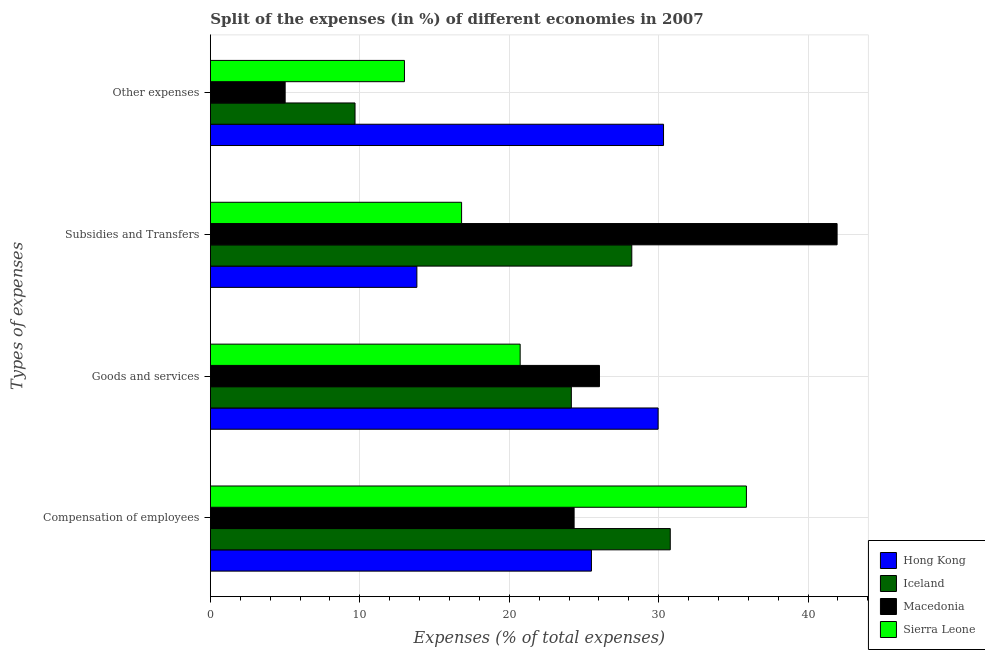Are the number of bars per tick equal to the number of legend labels?
Make the answer very short. Yes. Are the number of bars on each tick of the Y-axis equal?
Ensure brevity in your answer.  Yes. How many bars are there on the 4th tick from the bottom?
Your answer should be compact. 4. What is the label of the 1st group of bars from the top?
Give a very brief answer. Other expenses. What is the percentage of amount spent on other expenses in Sierra Leone?
Your answer should be compact. 12.99. Across all countries, what is the maximum percentage of amount spent on compensation of employees?
Provide a succinct answer. 35.87. Across all countries, what is the minimum percentage of amount spent on other expenses?
Your answer should be compact. 5. In which country was the percentage of amount spent on goods and services maximum?
Offer a very short reply. Hong Kong. In which country was the percentage of amount spent on compensation of employees minimum?
Your answer should be very brief. Macedonia. What is the total percentage of amount spent on subsidies in the graph?
Make the answer very short. 100.78. What is the difference between the percentage of amount spent on subsidies in Iceland and that in Sierra Leone?
Make the answer very short. 11.39. What is the difference between the percentage of amount spent on other expenses in Iceland and the percentage of amount spent on goods and services in Macedonia?
Provide a short and direct response. -16.36. What is the average percentage of amount spent on compensation of employees per country?
Offer a very short reply. 29.12. What is the difference between the percentage of amount spent on subsidies and percentage of amount spent on other expenses in Iceland?
Give a very brief answer. 18.52. In how many countries, is the percentage of amount spent on compensation of employees greater than 32 %?
Your answer should be compact. 1. What is the ratio of the percentage of amount spent on goods and services in Macedonia to that in Sierra Leone?
Ensure brevity in your answer.  1.26. Is the difference between the percentage of amount spent on subsidies in Macedonia and Hong Kong greater than the difference between the percentage of amount spent on goods and services in Macedonia and Hong Kong?
Your response must be concise. Yes. What is the difference between the highest and the second highest percentage of amount spent on subsidies?
Your answer should be very brief. 13.74. What is the difference between the highest and the lowest percentage of amount spent on goods and services?
Offer a very short reply. 9.23. In how many countries, is the percentage of amount spent on subsidies greater than the average percentage of amount spent on subsidies taken over all countries?
Provide a succinct answer. 2. Is the sum of the percentage of amount spent on subsidies in Iceland and Macedonia greater than the maximum percentage of amount spent on other expenses across all countries?
Offer a terse response. Yes. Is it the case that in every country, the sum of the percentage of amount spent on other expenses and percentage of amount spent on subsidies is greater than the sum of percentage of amount spent on compensation of employees and percentage of amount spent on goods and services?
Keep it short and to the point. No. What does the 3rd bar from the top in Subsidies and Transfers represents?
Keep it short and to the point. Iceland. What does the 2nd bar from the bottom in Goods and services represents?
Provide a short and direct response. Iceland. Is it the case that in every country, the sum of the percentage of amount spent on compensation of employees and percentage of amount spent on goods and services is greater than the percentage of amount spent on subsidies?
Your answer should be compact. Yes. How many bars are there?
Provide a succinct answer. 16. How many countries are there in the graph?
Give a very brief answer. 4. What is the difference between two consecutive major ticks on the X-axis?
Keep it short and to the point. 10. Are the values on the major ticks of X-axis written in scientific E-notation?
Your response must be concise. No. Does the graph contain any zero values?
Offer a very short reply. No. What is the title of the graph?
Your answer should be very brief. Split of the expenses (in %) of different economies in 2007. Does "Venezuela" appear as one of the legend labels in the graph?
Your answer should be compact. No. What is the label or title of the X-axis?
Offer a very short reply. Expenses (% of total expenses). What is the label or title of the Y-axis?
Keep it short and to the point. Types of expenses. What is the Expenses (% of total expenses) in Hong Kong in Compensation of employees?
Give a very brief answer. 25.5. What is the Expenses (% of total expenses) of Iceland in Compensation of employees?
Offer a terse response. 30.78. What is the Expenses (% of total expenses) of Macedonia in Compensation of employees?
Your response must be concise. 24.34. What is the Expenses (% of total expenses) of Sierra Leone in Compensation of employees?
Make the answer very short. 35.87. What is the Expenses (% of total expenses) of Hong Kong in Goods and services?
Ensure brevity in your answer.  29.97. What is the Expenses (% of total expenses) of Iceland in Goods and services?
Provide a succinct answer. 24.16. What is the Expenses (% of total expenses) in Macedonia in Goods and services?
Provide a succinct answer. 26.04. What is the Expenses (% of total expenses) of Sierra Leone in Goods and services?
Your answer should be compact. 20.73. What is the Expenses (% of total expenses) in Hong Kong in Subsidies and Transfers?
Give a very brief answer. 13.82. What is the Expenses (% of total expenses) of Iceland in Subsidies and Transfers?
Make the answer very short. 28.2. What is the Expenses (% of total expenses) of Macedonia in Subsidies and Transfers?
Provide a succinct answer. 41.94. What is the Expenses (% of total expenses) of Sierra Leone in Subsidies and Transfers?
Your answer should be compact. 16.81. What is the Expenses (% of total expenses) of Hong Kong in Other expenses?
Offer a very short reply. 30.33. What is the Expenses (% of total expenses) in Iceland in Other expenses?
Your response must be concise. 9.68. What is the Expenses (% of total expenses) in Macedonia in Other expenses?
Your answer should be very brief. 5. What is the Expenses (% of total expenses) of Sierra Leone in Other expenses?
Ensure brevity in your answer.  12.99. Across all Types of expenses, what is the maximum Expenses (% of total expenses) in Hong Kong?
Give a very brief answer. 30.33. Across all Types of expenses, what is the maximum Expenses (% of total expenses) in Iceland?
Your answer should be very brief. 30.78. Across all Types of expenses, what is the maximum Expenses (% of total expenses) of Macedonia?
Offer a terse response. 41.94. Across all Types of expenses, what is the maximum Expenses (% of total expenses) in Sierra Leone?
Provide a succinct answer. 35.87. Across all Types of expenses, what is the minimum Expenses (% of total expenses) of Hong Kong?
Offer a terse response. 13.82. Across all Types of expenses, what is the minimum Expenses (% of total expenses) of Iceland?
Provide a succinct answer. 9.68. Across all Types of expenses, what is the minimum Expenses (% of total expenses) of Macedonia?
Give a very brief answer. 5. Across all Types of expenses, what is the minimum Expenses (% of total expenses) in Sierra Leone?
Ensure brevity in your answer.  12.99. What is the total Expenses (% of total expenses) in Hong Kong in the graph?
Your answer should be very brief. 99.61. What is the total Expenses (% of total expenses) of Iceland in the graph?
Ensure brevity in your answer.  92.82. What is the total Expenses (% of total expenses) of Macedonia in the graph?
Ensure brevity in your answer.  97.33. What is the total Expenses (% of total expenses) of Sierra Leone in the graph?
Provide a succinct answer. 86.4. What is the difference between the Expenses (% of total expenses) in Hong Kong in Compensation of employees and that in Goods and services?
Your response must be concise. -4.46. What is the difference between the Expenses (% of total expenses) in Iceland in Compensation of employees and that in Goods and services?
Your answer should be compact. 6.62. What is the difference between the Expenses (% of total expenses) of Macedonia in Compensation of employees and that in Goods and services?
Keep it short and to the point. -1.7. What is the difference between the Expenses (% of total expenses) in Sierra Leone in Compensation of employees and that in Goods and services?
Your answer should be compact. 15.14. What is the difference between the Expenses (% of total expenses) in Hong Kong in Compensation of employees and that in Subsidies and Transfers?
Ensure brevity in your answer.  11.68. What is the difference between the Expenses (% of total expenses) in Iceland in Compensation of employees and that in Subsidies and Transfers?
Your response must be concise. 2.57. What is the difference between the Expenses (% of total expenses) in Macedonia in Compensation of employees and that in Subsidies and Transfers?
Keep it short and to the point. -17.6. What is the difference between the Expenses (% of total expenses) of Sierra Leone in Compensation of employees and that in Subsidies and Transfers?
Make the answer very short. 19.06. What is the difference between the Expenses (% of total expenses) in Hong Kong in Compensation of employees and that in Other expenses?
Offer a very short reply. -4.82. What is the difference between the Expenses (% of total expenses) of Iceland in Compensation of employees and that in Other expenses?
Provide a short and direct response. 21.1. What is the difference between the Expenses (% of total expenses) in Macedonia in Compensation of employees and that in Other expenses?
Keep it short and to the point. 19.34. What is the difference between the Expenses (% of total expenses) in Sierra Leone in Compensation of employees and that in Other expenses?
Keep it short and to the point. 22.89. What is the difference between the Expenses (% of total expenses) of Hong Kong in Goods and services and that in Subsidies and Transfers?
Make the answer very short. 16.15. What is the difference between the Expenses (% of total expenses) of Iceland in Goods and services and that in Subsidies and Transfers?
Your answer should be compact. -4.05. What is the difference between the Expenses (% of total expenses) in Macedonia in Goods and services and that in Subsidies and Transfers?
Your answer should be very brief. -15.9. What is the difference between the Expenses (% of total expenses) in Sierra Leone in Goods and services and that in Subsidies and Transfers?
Ensure brevity in your answer.  3.92. What is the difference between the Expenses (% of total expenses) of Hong Kong in Goods and services and that in Other expenses?
Give a very brief answer. -0.36. What is the difference between the Expenses (% of total expenses) in Iceland in Goods and services and that in Other expenses?
Offer a terse response. 14.48. What is the difference between the Expenses (% of total expenses) in Macedonia in Goods and services and that in Other expenses?
Give a very brief answer. 21.04. What is the difference between the Expenses (% of total expenses) in Sierra Leone in Goods and services and that in Other expenses?
Keep it short and to the point. 7.74. What is the difference between the Expenses (% of total expenses) in Hong Kong in Subsidies and Transfers and that in Other expenses?
Ensure brevity in your answer.  -16.51. What is the difference between the Expenses (% of total expenses) of Iceland in Subsidies and Transfers and that in Other expenses?
Keep it short and to the point. 18.52. What is the difference between the Expenses (% of total expenses) of Macedonia in Subsidies and Transfers and that in Other expenses?
Your response must be concise. 36.94. What is the difference between the Expenses (% of total expenses) in Sierra Leone in Subsidies and Transfers and that in Other expenses?
Provide a succinct answer. 3.82. What is the difference between the Expenses (% of total expenses) in Hong Kong in Compensation of employees and the Expenses (% of total expenses) in Iceland in Goods and services?
Offer a terse response. 1.35. What is the difference between the Expenses (% of total expenses) of Hong Kong in Compensation of employees and the Expenses (% of total expenses) of Macedonia in Goods and services?
Offer a terse response. -0.54. What is the difference between the Expenses (% of total expenses) in Hong Kong in Compensation of employees and the Expenses (% of total expenses) in Sierra Leone in Goods and services?
Offer a very short reply. 4.77. What is the difference between the Expenses (% of total expenses) of Iceland in Compensation of employees and the Expenses (% of total expenses) of Macedonia in Goods and services?
Ensure brevity in your answer.  4.74. What is the difference between the Expenses (% of total expenses) in Iceland in Compensation of employees and the Expenses (% of total expenses) in Sierra Leone in Goods and services?
Give a very brief answer. 10.05. What is the difference between the Expenses (% of total expenses) of Macedonia in Compensation of employees and the Expenses (% of total expenses) of Sierra Leone in Goods and services?
Ensure brevity in your answer.  3.61. What is the difference between the Expenses (% of total expenses) of Hong Kong in Compensation of employees and the Expenses (% of total expenses) of Iceland in Subsidies and Transfers?
Make the answer very short. -2.7. What is the difference between the Expenses (% of total expenses) of Hong Kong in Compensation of employees and the Expenses (% of total expenses) of Macedonia in Subsidies and Transfers?
Offer a terse response. -16.44. What is the difference between the Expenses (% of total expenses) in Hong Kong in Compensation of employees and the Expenses (% of total expenses) in Sierra Leone in Subsidies and Transfers?
Keep it short and to the point. 8.69. What is the difference between the Expenses (% of total expenses) in Iceland in Compensation of employees and the Expenses (% of total expenses) in Macedonia in Subsidies and Transfers?
Offer a terse response. -11.17. What is the difference between the Expenses (% of total expenses) in Iceland in Compensation of employees and the Expenses (% of total expenses) in Sierra Leone in Subsidies and Transfers?
Keep it short and to the point. 13.97. What is the difference between the Expenses (% of total expenses) of Macedonia in Compensation of employees and the Expenses (% of total expenses) of Sierra Leone in Subsidies and Transfers?
Make the answer very short. 7.53. What is the difference between the Expenses (% of total expenses) in Hong Kong in Compensation of employees and the Expenses (% of total expenses) in Iceland in Other expenses?
Ensure brevity in your answer.  15.82. What is the difference between the Expenses (% of total expenses) in Hong Kong in Compensation of employees and the Expenses (% of total expenses) in Macedonia in Other expenses?
Offer a very short reply. 20.5. What is the difference between the Expenses (% of total expenses) of Hong Kong in Compensation of employees and the Expenses (% of total expenses) of Sierra Leone in Other expenses?
Provide a succinct answer. 12.51. What is the difference between the Expenses (% of total expenses) of Iceland in Compensation of employees and the Expenses (% of total expenses) of Macedonia in Other expenses?
Your answer should be compact. 25.77. What is the difference between the Expenses (% of total expenses) of Iceland in Compensation of employees and the Expenses (% of total expenses) of Sierra Leone in Other expenses?
Offer a terse response. 17.79. What is the difference between the Expenses (% of total expenses) of Macedonia in Compensation of employees and the Expenses (% of total expenses) of Sierra Leone in Other expenses?
Ensure brevity in your answer.  11.35. What is the difference between the Expenses (% of total expenses) in Hong Kong in Goods and services and the Expenses (% of total expenses) in Iceland in Subsidies and Transfers?
Your answer should be very brief. 1.76. What is the difference between the Expenses (% of total expenses) in Hong Kong in Goods and services and the Expenses (% of total expenses) in Macedonia in Subsidies and Transfers?
Offer a very short reply. -11.98. What is the difference between the Expenses (% of total expenses) of Hong Kong in Goods and services and the Expenses (% of total expenses) of Sierra Leone in Subsidies and Transfers?
Offer a terse response. 13.15. What is the difference between the Expenses (% of total expenses) in Iceland in Goods and services and the Expenses (% of total expenses) in Macedonia in Subsidies and Transfers?
Provide a short and direct response. -17.79. What is the difference between the Expenses (% of total expenses) in Iceland in Goods and services and the Expenses (% of total expenses) in Sierra Leone in Subsidies and Transfers?
Give a very brief answer. 7.34. What is the difference between the Expenses (% of total expenses) in Macedonia in Goods and services and the Expenses (% of total expenses) in Sierra Leone in Subsidies and Transfers?
Your answer should be very brief. 9.23. What is the difference between the Expenses (% of total expenses) in Hong Kong in Goods and services and the Expenses (% of total expenses) in Iceland in Other expenses?
Provide a succinct answer. 20.29. What is the difference between the Expenses (% of total expenses) of Hong Kong in Goods and services and the Expenses (% of total expenses) of Macedonia in Other expenses?
Your answer should be very brief. 24.96. What is the difference between the Expenses (% of total expenses) in Hong Kong in Goods and services and the Expenses (% of total expenses) in Sierra Leone in Other expenses?
Provide a succinct answer. 16.98. What is the difference between the Expenses (% of total expenses) in Iceland in Goods and services and the Expenses (% of total expenses) in Macedonia in Other expenses?
Ensure brevity in your answer.  19.15. What is the difference between the Expenses (% of total expenses) in Iceland in Goods and services and the Expenses (% of total expenses) in Sierra Leone in Other expenses?
Provide a short and direct response. 11.17. What is the difference between the Expenses (% of total expenses) of Macedonia in Goods and services and the Expenses (% of total expenses) of Sierra Leone in Other expenses?
Your answer should be very brief. 13.05. What is the difference between the Expenses (% of total expenses) in Hong Kong in Subsidies and Transfers and the Expenses (% of total expenses) in Iceland in Other expenses?
Provide a succinct answer. 4.14. What is the difference between the Expenses (% of total expenses) of Hong Kong in Subsidies and Transfers and the Expenses (% of total expenses) of Macedonia in Other expenses?
Ensure brevity in your answer.  8.82. What is the difference between the Expenses (% of total expenses) of Hong Kong in Subsidies and Transfers and the Expenses (% of total expenses) of Sierra Leone in Other expenses?
Provide a succinct answer. 0.83. What is the difference between the Expenses (% of total expenses) in Iceland in Subsidies and Transfers and the Expenses (% of total expenses) in Macedonia in Other expenses?
Offer a terse response. 23.2. What is the difference between the Expenses (% of total expenses) in Iceland in Subsidies and Transfers and the Expenses (% of total expenses) in Sierra Leone in Other expenses?
Keep it short and to the point. 15.22. What is the difference between the Expenses (% of total expenses) in Macedonia in Subsidies and Transfers and the Expenses (% of total expenses) in Sierra Leone in Other expenses?
Offer a very short reply. 28.96. What is the average Expenses (% of total expenses) in Hong Kong per Types of expenses?
Provide a short and direct response. 24.9. What is the average Expenses (% of total expenses) of Iceland per Types of expenses?
Give a very brief answer. 23.2. What is the average Expenses (% of total expenses) in Macedonia per Types of expenses?
Your answer should be compact. 24.33. What is the average Expenses (% of total expenses) in Sierra Leone per Types of expenses?
Provide a short and direct response. 21.6. What is the difference between the Expenses (% of total expenses) of Hong Kong and Expenses (% of total expenses) of Iceland in Compensation of employees?
Keep it short and to the point. -5.28. What is the difference between the Expenses (% of total expenses) in Hong Kong and Expenses (% of total expenses) in Macedonia in Compensation of employees?
Your answer should be compact. 1.16. What is the difference between the Expenses (% of total expenses) of Hong Kong and Expenses (% of total expenses) of Sierra Leone in Compensation of employees?
Offer a very short reply. -10.37. What is the difference between the Expenses (% of total expenses) of Iceland and Expenses (% of total expenses) of Macedonia in Compensation of employees?
Offer a terse response. 6.44. What is the difference between the Expenses (% of total expenses) in Iceland and Expenses (% of total expenses) in Sierra Leone in Compensation of employees?
Ensure brevity in your answer.  -5.1. What is the difference between the Expenses (% of total expenses) in Macedonia and Expenses (% of total expenses) in Sierra Leone in Compensation of employees?
Keep it short and to the point. -11.53. What is the difference between the Expenses (% of total expenses) of Hong Kong and Expenses (% of total expenses) of Iceland in Goods and services?
Give a very brief answer. 5.81. What is the difference between the Expenses (% of total expenses) in Hong Kong and Expenses (% of total expenses) in Macedonia in Goods and services?
Provide a succinct answer. 3.93. What is the difference between the Expenses (% of total expenses) in Hong Kong and Expenses (% of total expenses) in Sierra Leone in Goods and services?
Offer a very short reply. 9.23. What is the difference between the Expenses (% of total expenses) of Iceland and Expenses (% of total expenses) of Macedonia in Goods and services?
Make the answer very short. -1.88. What is the difference between the Expenses (% of total expenses) of Iceland and Expenses (% of total expenses) of Sierra Leone in Goods and services?
Provide a succinct answer. 3.43. What is the difference between the Expenses (% of total expenses) of Macedonia and Expenses (% of total expenses) of Sierra Leone in Goods and services?
Provide a succinct answer. 5.31. What is the difference between the Expenses (% of total expenses) of Hong Kong and Expenses (% of total expenses) of Iceland in Subsidies and Transfers?
Your response must be concise. -14.38. What is the difference between the Expenses (% of total expenses) in Hong Kong and Expenses (% of total expenses) in Macedonia in Subsidies and Transfers?
Your answer should be very brief. -28.12. What is the difference between the Expenses (% of total expenses) in Hong Kong and Expenses (% of total expenses) in Sierra Leone in Subsidies and Transfers?
Your answer should be very brief. -2.99. What is the difference between the Expenses (% of total expenses) of Iceland and Expenses (% of total expenses) of Macedonia in Subsidies and Transfers?
Give a very brief answer. -13.74. What is the difference between the Expenses (% of total expenses) in Iceland and Expenses (% of total expenses) in Sierra Leone in Subsidies and Transfers?
Offer a very short reply. 11.39. What is the difference between the Expenses (% of total expenses) of Macedonia and Expenses (% of total expenses) of Sierra Leone in Subsidies and Transfers?
Your answer should be compact. 25.13. What is the difference between the Expenses (% of total expenses) of Hong Kong and Expenses (% of total expenses) of Iceland in Other expenses?
Give a very brief answer. 20.65. What is the difference between the Expenses (% of total expenses) in Hong Kong and Expenses (% of total expenses) in Macedonia in Other expenses?
Provide a short and direct response. 25.32. What is the difference between the Expenses (% of total expenses) in Hong Kong and Expenses (% of total expenses) in Sierra Leone in Other expenses?
Offer a terse response. 17.34. What is the difference between the Expenses (% of total expenses) of Iceland and Expenses (% of total expenses) of Macedonia in Other expenses?
Provide a succinct answer. 4.68. What is the difference between the Expenses (% of total expenses) of Iceland and Expenses (% of total expenses) of Sierra Leone in Other expenses?
Your answer should be compact. -3.31. What is the difference between the Expenses (% of total expenses) of Macedonia and Expenses (% of total expenses) of Sierra Leone in Other expenses?
Make the answer very short. -7.98. What is the ratio of the Expenses (% of total expenses) of Hong Kong in Compensation of employees to that in Goods and services?
Keep it short and to the point. 0.85. What is the ratio of the Expenses (% of total expenses) of Iceland in Compensation of employees to that in Goods and services?
Your response must be concise. 1.27. What is the ratio of the Expenses (% of total expenses) in Macedonia in Compensation of employees to that in Goods and services?
Your response must be concise. 0.93. What is the ratio of the Expenses (% of total expenses) in Sierra Leone in Compensation of employees to that in Goods and services?
Ensure brevity in your answer.  1.73. What is the ratio of the Expenses (% of total expenses) of Hong Kong in Compensation of employees to that in Subsidies and Transfers?
Provide a succinct answer. 1.85. What is the ratio of the Expenses (% of total expenses) of Iceland in Compensation of employees to that in Subsidies and Transfers?
Make the answer very short. 1.09. What is the ratio of the Expenses (% of total expenses) of Macedonia in Compensation of employees to that in Subsidies and Transfers?
Your response must be concise. 0.58. What is the ratio of the Expenses (% of total expenses) of Sierra Leone in Compensation of employees to that in Subsidies and Transfers?
Your answer should be very brief. 2.13. What is the ratio of the Expenses (% of total expenses) of Hong Kong in Compensation of employees to that in Other expenses?
Your response must be concise. 0.84. What is the ratio of the Expenses (% of total expenses) of Iceland in Compensation of employees to that in Other expenses?
Offer a terse response. 3.18. What is the ratio of the Expenses (% of total expenses) of Macedonia in Compensation of employees to that in Other expenses?
Your response must be concise. 4.86. What is the ratio of the Expenses (% of total expenses) in Sierra Leone in Compensation of employees to that in Other expenses?
Provide a succinct answer. 2.76. What is the ratio of the Expenses (% of total expenses) in Hong Kong in Goods and services to that in Subsidies and Transfers?
Your response must be concise. 2.17. What is the ratio of the Expenses (% of total expenses) in Iceland in Goods and services to that in Subsidies and Transfers?
Give a very brief answer. 0.86. What is the ratio of the Expenses (% of total expenses) of Macedonia in Goods and services to that in Subsidies and Transfers?
Provide a succinct answer. 0.62. What is the ratio of the Expenses (% of total expenses) of Sierra Leone in Goods and services to that in Subsidies and Transfers?
Your response must be concise. 1.23. What is the ratio of the Expenses (% of total expenses) of Iceland in Goods and services to that in Other expenses?
Offer a terse response. 2.5. What is the ratio of the Expenses (% of total expenses) in Macedonia in Goods and services to that in Other expenses?
Give a very brief answer. 5.2. What is the ratio of the Expenses (% of total expenses) in Sierra Leone in Goods and services to that in Other expenses?
Ensure brevity in your answer.  1.6. What is the ratio of the Expenses (% of total expenses) in Hong Kong in Subsidies and Transfers to that in Other expenses?
Make the answer very short. 0.46. What is the ratio of the Expenses (% of total expenses) in Iceland in Subsidies and Transfers to that in Other expenses?
Give a very brief answer. 2.91. What is the ratio of the Expenses (% of total expenses) in Macedonia in Subsidies and Transfers to that in Other expenses?
Make the answer very short. 8.38. What is the ratio of the Expenses (% of total expenses) of Sierra Leone in Subsidies and Transfers to that in Other expenses?
Ensure brevity in your answer.  1.29. What is the difference between the highest and the second highest Expenses (% of total expenses) of Hong Kong?
Keep it short and to the point. 0.36. What is the difference between the highest and the second highest Expenses (% of total expenses) in Iceland?
Your answer should be compact. 2.57. What is the difference between the highest and the second highest Expenses (% of total expenses) of Macedonia?
Offer a terse response. 15.9. What is the difference between the highest and the second highest Expenses (% of total expenses) in Sierra Leone?
Your answer should be compact. 15.14. What is the difference between the highest and the lowest Expenses (% of total expenses) in Hong Kong?
Provide a short and direct response. 16.51. What is the difference between the highest and the lowest Expenses (% of total expenses) in Iceland?
Offer a terse response. 21.1. What is the difference between the highest and the lowest Expenses (% of total expenses) of Macedonia?
Your answer should be very brief. 36.94. What is the difference between the highest and the lowest Expenses (% of total expenses) in Sierra Leone?
Give a very brief answer. 22.89. 